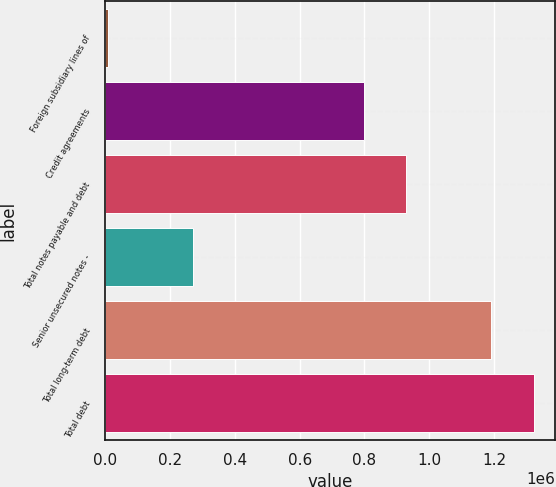Convert chart. <chart><loc_0><loc_0><loc_500><loc_500><bar_chart><fcel>Foreign subsidiary lines of<fcel>Credit agreements<fcel>Total notes payable and debt<fcel>Senior unsecured notes -<fcel>Total long-term debt<fcel>Total debt<nl><fcel>8346<fcel>797346<fcel>928846<fcel>271346<fcel>1.19e+06<fcel>1.32335e+06<nl></chart> 